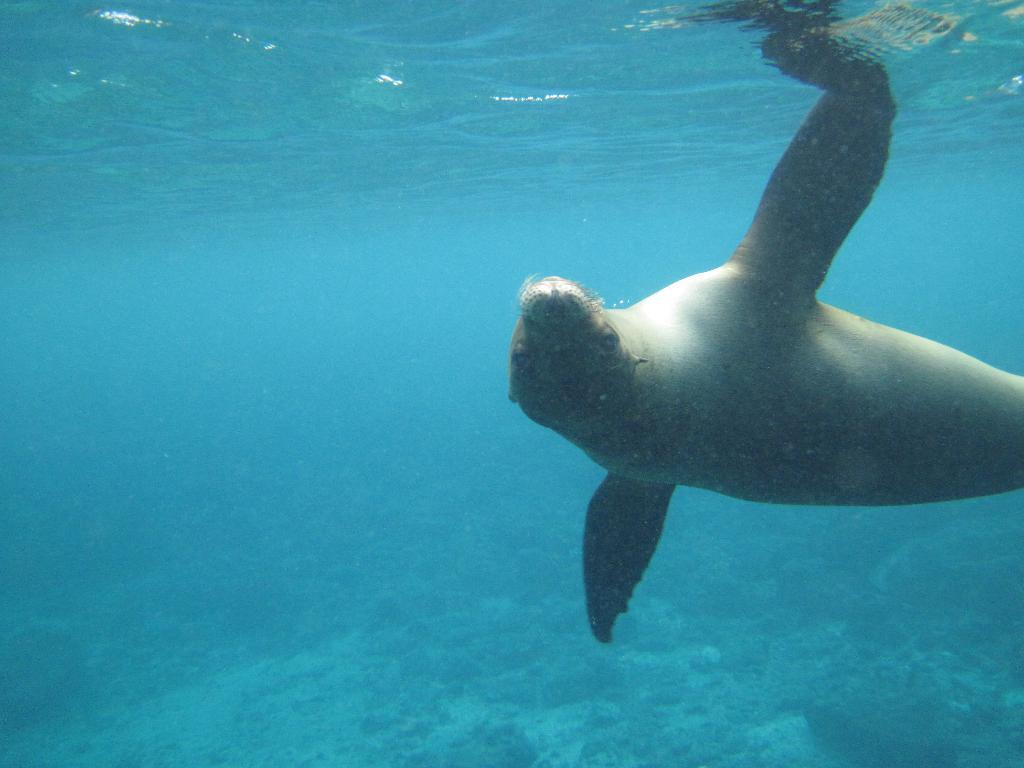What type of animal can be seen in the image? There is a water animal in the image. What is the primary element in which the animal is situated? The animal is situated in water. What type of lettuce can be seen growing in the image? There is no lettuce present in the image; it features a water animal in water. 